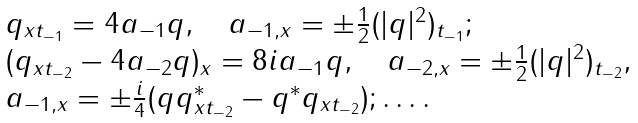<formula> <loc_0><loc_0><loc_500><loc_500>\begin{array} { l } q _ { x t _ { - 1 } } = 4 a _ { - 1 } q , \quad a _ { - 1 , x } = \pm \frac { 1 } { 2 } ( | q | ^ { 2 } ) _ { t _ { - 1 } } ; \\ ( q _ { x t _ { - 2 } } - 4 a _ { - 2 } q ) _ { x } = 8 i a _ { - 1 } q , \quad a _ { - 2 , x } = \pm \frac { 1 } { 2 } ( | q | ^ { 2 } ) _ { t _ { - 2 } } , \\ a _ { - 1 , x } = \pm \frac { i } 4 ( q q _ { x t _ { - 2 } } ^ { * } - q ^ { * } q _ { x t _ { - 2 } } ) ; \dots . \end{array}</formula> 